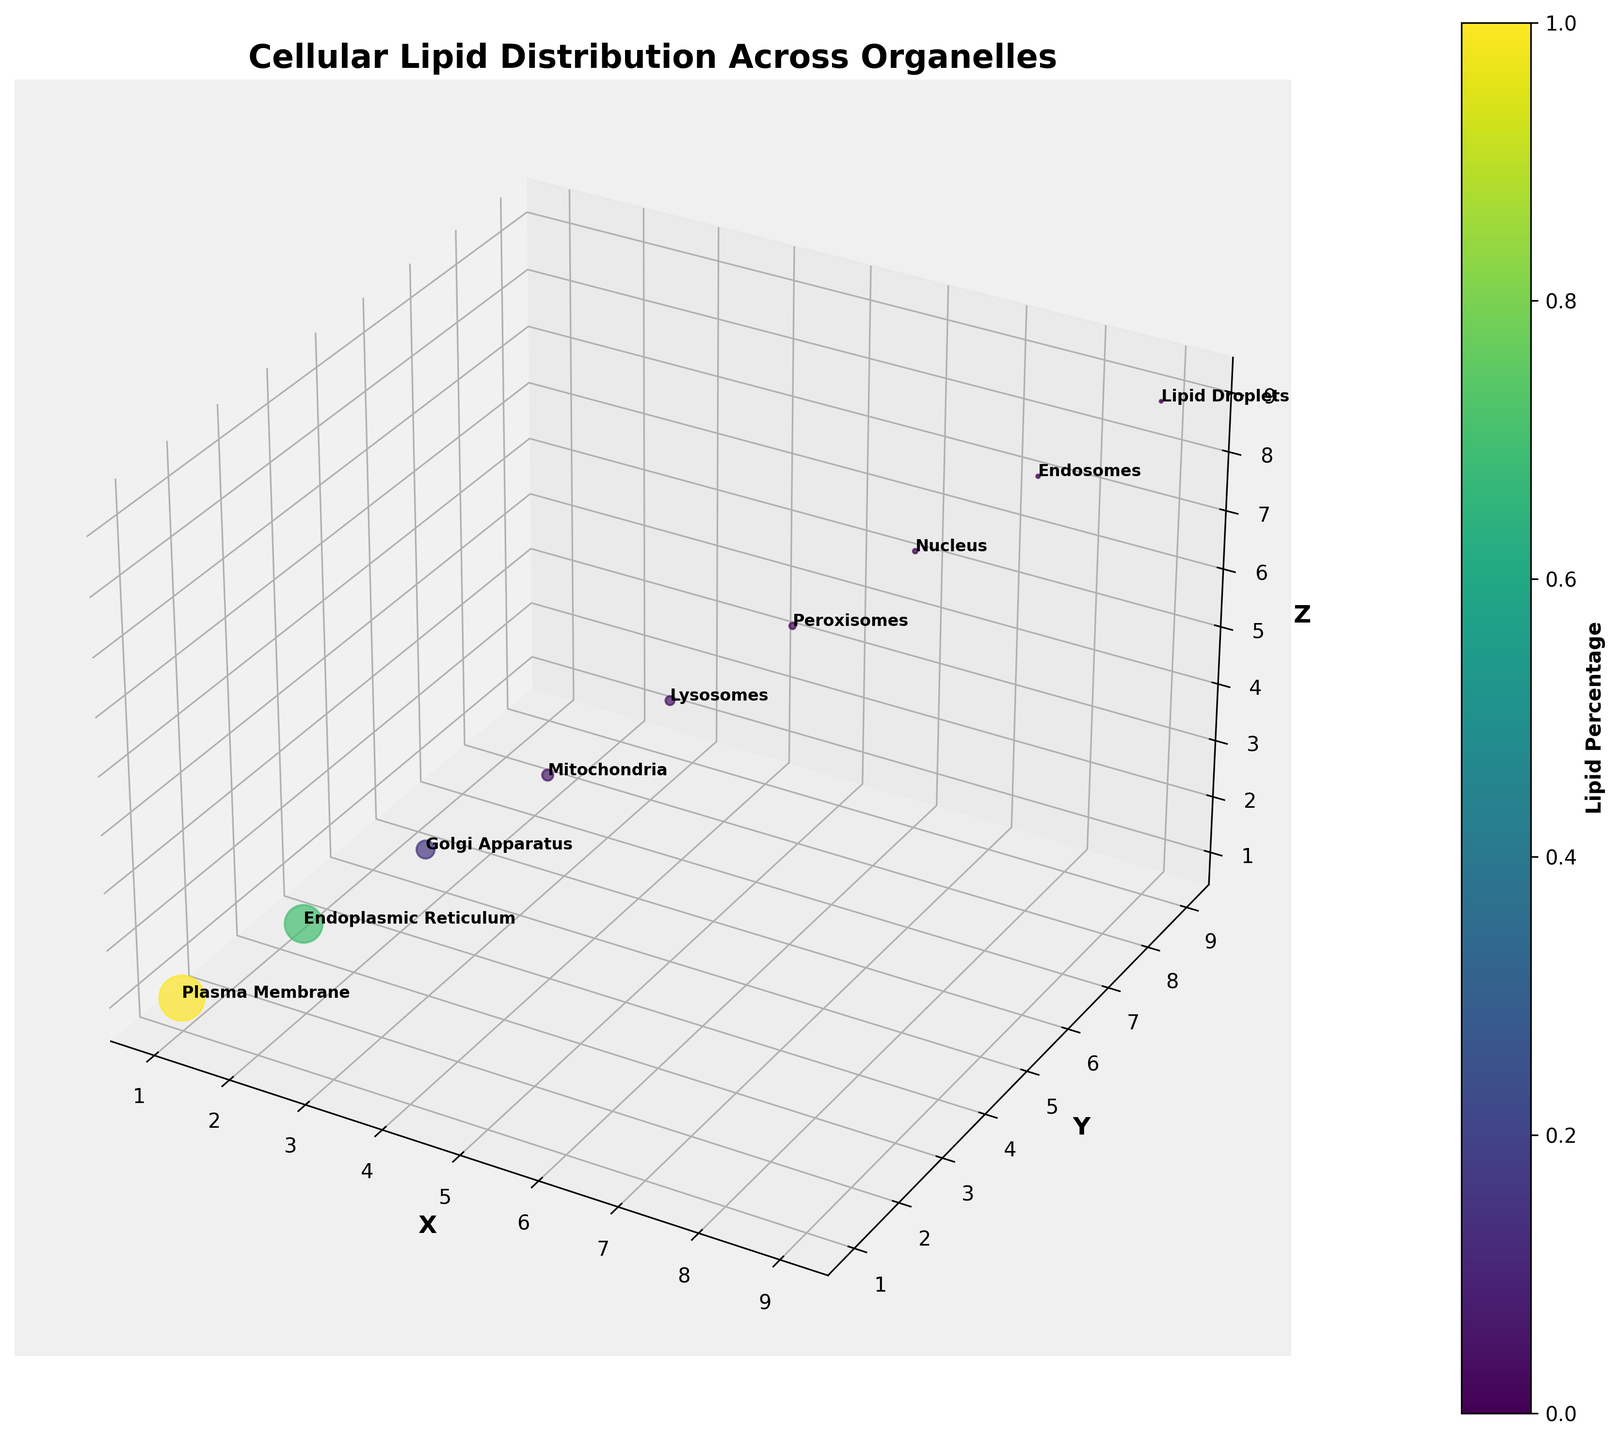What is the title of the graph? The title of the graph is typically found at the top and provides a summary of what the graph represents. In this case, it gives a snapshot of the overall content and focus of the graph.
Answer: Cellular Lipid Distribution Across Organelles What organelle has the highest lipid percentage? By looking at the bubble sizes and their corresponding labels in the 3D scatter plot, you can identify which organelle has the largest bubble. The title "Plasma Membrane" is attached to the largest bubble, which corresponds to the highest lipid percentage.
Answer: Plasma Membrane How many data points are represented in the plot? The number of data points corresponds to the number of bubbles plotted in the 3D space. Each bubble represents an organelle, and since we see a single bubble per organelle, you just count them. Based on the data provided, there are 9 organelles listed.
Answer: 9 Which organelle has the smallest lipid percentage? By examining the smallest bubble in the 3D plot and checking its label, you identify that the title of the smallest bubble is "Lipid Droplets."
Answer: Lipid Droplets Which organelle is closest to the origin point (0,0,0) in the graph? The closest organelle to the origin would have coordinates closest to (0,0,0). From the data, the "Plasma Membrane" at (1, 1, 1) is the nearest point to the origin.
Answer: Plasma Membrane What color range represents the lipid percentage in the plot? The color bar on the side of the plot (color bar legend) shows the colors mapped to different lipid percentages. The graph uses a gradient from the 'viridis' colormap ranging from purple (low lipid percentage) to yellow/green (high lipid percentage).
Answer: Purple to Yellow/Green How widely are the lipid percentages spread across different organelles? To determine the spread, consider both range and color variation. The values range from 0.2% in Lipid Droplets to 50% in Plasma Membrane, indicating a wide spread in lipid percentages across the organelles.
Answer: From 0.2% to 50% Which organelle has a lipid percentage nearest to the average of all organelles? First, calculate the average lipid percentage: (50 + 35 + 8 + 3 + 2 + 1 + 0.5 + 0.3 + 0.2) / 9 = 11.11%. The Golgi Apparatus, with 8%, is the closest to this average.
Answer: Golgi Apparatus What is the total lipid percentage across all organelles? Summing all values listed under "Lipid_Percentage" from the data: 50 + 35 + 8 + 3 + 2 + 1 + 0.5 + 0.3 + 0.2 = 100
Answer: 100 